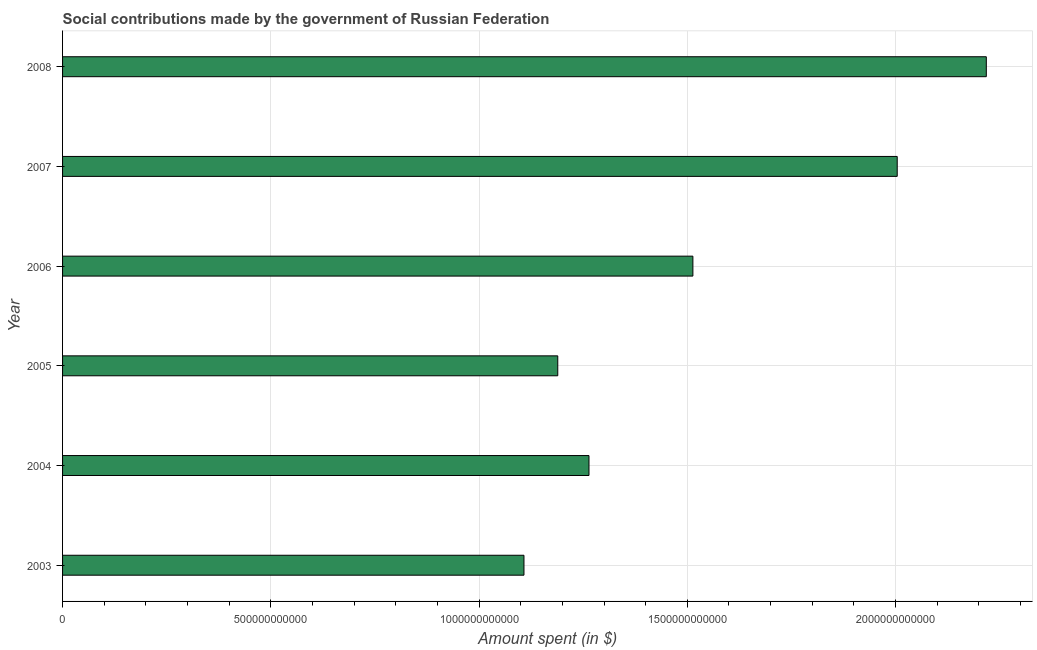Does the graph contain any zero values?
Your response must be concise. No. What is the title of the graph?
Provide a short and direct response. Social contributions made by the government of Russian Federation. What is the label or title of the X-axis?
Keep it short and to the point. Amount spent (in $). What is the label or title of the Y-axis?
Make the answer very short. Year. What is the amount spent in making social contributions in 2007?
Your answer should be compact. 2.00e+12. Across all years, what is the maximum amount spent in making social contributions?
Your response must be concise. 2.22e+12. Across all years, what is the minimum amount spent in making social contributions?
Ensure brevity in your answer.  1.11e+12. In which year was the amount spent in making social contributions maximum?
Offer a very short reply. 2008. What is the sum of the amount spent in making social contributions?
Give a very brief answer. 9.30e+12. What is the difference between the amount spent in making social contributions in 2006 and 2008?
Make the answer very short. -7.04e+11. What is the average amount spent in making social contributions per year?
Keep it short and to the point. 1.55e+12. What is the median amount spent in making social contributions?
Provide a short and direct response. 1.39e+12. In how many years, is the amount spent in making social contributions greater than 1900000000000 $?
Your answer should be compact. 2. Do a majority of the years between 2003 and 2005 (inclusive) have amount spent in making social contributions greater than 1000000000000 $?
Give a very brief answer. Yes. What is the ratio of the amount spent in making social contributions in 2007 to that in 2008?
Offer a very short reply. 0.9. Is the amount spent in making social contributions in 2005 less than that in 2006?
Keep it short and to the point. Yes. Is the difference between the amount spent in making social contributions in 2006 and 2008 greater than the difference between any two years?
Give a very brief answer. No. What is the difference between the highest and the second highest amount spent in making social contributions?
Provide a succinct answer. 2.14e+11. What is the difference between the highest and the lowest amount spent in making social contributions?
Provide a short and direct response. 1.11e+12. How many bars are there?
Give a very brief answer. 6. How many years are there in the graph?
Provide a succinct answer. 6. What is the difference between two consecutive major ticks on the X-axis?
Provide a succinct answer. 5.00e+11. Are the values on the major ticks of X-axis written in scientific E-notation?
Ensure brevity in your answer.  No. What is the Amount spent (in $) in 2003?
Give a very brief answer. 1.11e+12. What is the Amount spent (in $) in 2004?
Your response must be concise. 1.26e+12. What is the Amount spent (in $) of 2005?
Your response must be concise. 1.19e+12. What is the Amount spent (in $) in 2006?
Provide a succinct answer. 1.51e+12. What is the Amount spent (in $) in 2007?
Offer a very short reply. 2.00e+12. What is the Amount spent (in $) in 2008?
Your response must be concise. 2.22e+12. What is the difference between the Amount spent (in $) in 2003 and 2004?
Make the answer very short. -1.56e+11. What is the difference between the Amount spent (in $) in 2003 and 2005?
Make the answer very short. -8.11e+1. What is the difference between the Amount spent (in $) in 2003 and 2006?
Provide a succinct answer. -4.06e+11. What is the difference between the Amount spent (in $) in 2003 and 2007?
Ensure brevity in your answer.  -8.96e+11. What is the difference between the Amount spent (in $) in 2003 and 2008?
Make the answer very short. -1.11e+12. What is the difference between the Amount spent (in $) in 2004 and 2005?
Ensure brevity in your answer.  7.49e+1. What is the difference between the Amount spent (in $) in 2004 and 2006?
Your answer should be very brief. -2.49e+11. What is the difference between the Amount spent (in $) in 2004 and 2007?
Keep it short and to the point. -7.40e+11. What is the difference between the Amount spent (in $) in 2004 and 2008?
Ensure brevity in your answer.  -9.54e+11. What is the difference between the Amount spent (in $) in 2005 and 2006?
Offer a very short reply. -3.24e+11. What is the difference between the Amount spent (in $) in 2005 and 2007?
Provide a short and direct response. -8.15e+11. What is the difference between the Amount spent (in $) in 2005 and 2008?
Ensure brevity in your answer.  -1.03e+12. What is the difference between the Amount spent (in $) in 2006 and 2007?
Your answer should be compact. -4.91e+11. What is the difference between the Amount spent (in $) in 2006 and 2008?
Your answer should be compact. -7.04e+11. What is the difference between the Amount spent (in $) in 2007 and 2008?
Ensure brevity in your answer.  -2.14e+11. What is the ratio of the Amount spent (in $) in 2003 to that in 2004?
Keep it short and to the point. 0.88. What is the ratio of the Amount spent (in $) in 2003 to that in 2005?
Keep it short and to the point. 0.93. What is the ratio of the Amount spent (in $) in 2003 to that in 2006?
Give a very brief answer. 0.73. What is the ratio of the Amount spent (in $) in 2003 to that in 2007?
Keep it short and to the point. 0.55. What is the ratio of the Amount spent (in $) in 2004 to that in 2005?
Offer a very short reply. 1.06. What is the ratio of the Amount spent (in $) in 2004 to that in 2006?
Your answer should be compact. 0.83. What is the ratio of the Amount spent (in $) in 2004 to that in 2007?
Provide a short and direct response. 0.63. What is the ratio of the Amount spent (in $) in 2004 to that in 2008?
Keep it short and to the point. 0.57. What is the ratio of the Amount spent (in $) in 2005 to that in 2006?
Make the answer very short. 0.79. What is the ratio of the Amount spent (in $) in 2005 to that in 2007?
Your answer should be very brief. 0.59. What is the ratio of the Amount spent (in $) in 2005 to that in 2008?
Offer a terse response. 0.54. What is the ratio of the Amount spent (in $) in 2006 to that in 2007?
Your response must be concise. 0.76. What is the ratio of the Amount spent (in $) in 2006 to that in 2008?
Your answer should be very brief. 0.68. What is the ratio of the Amount spent (in $) in 2007 to that in 2008?
Your response must be concise. 0.9. 